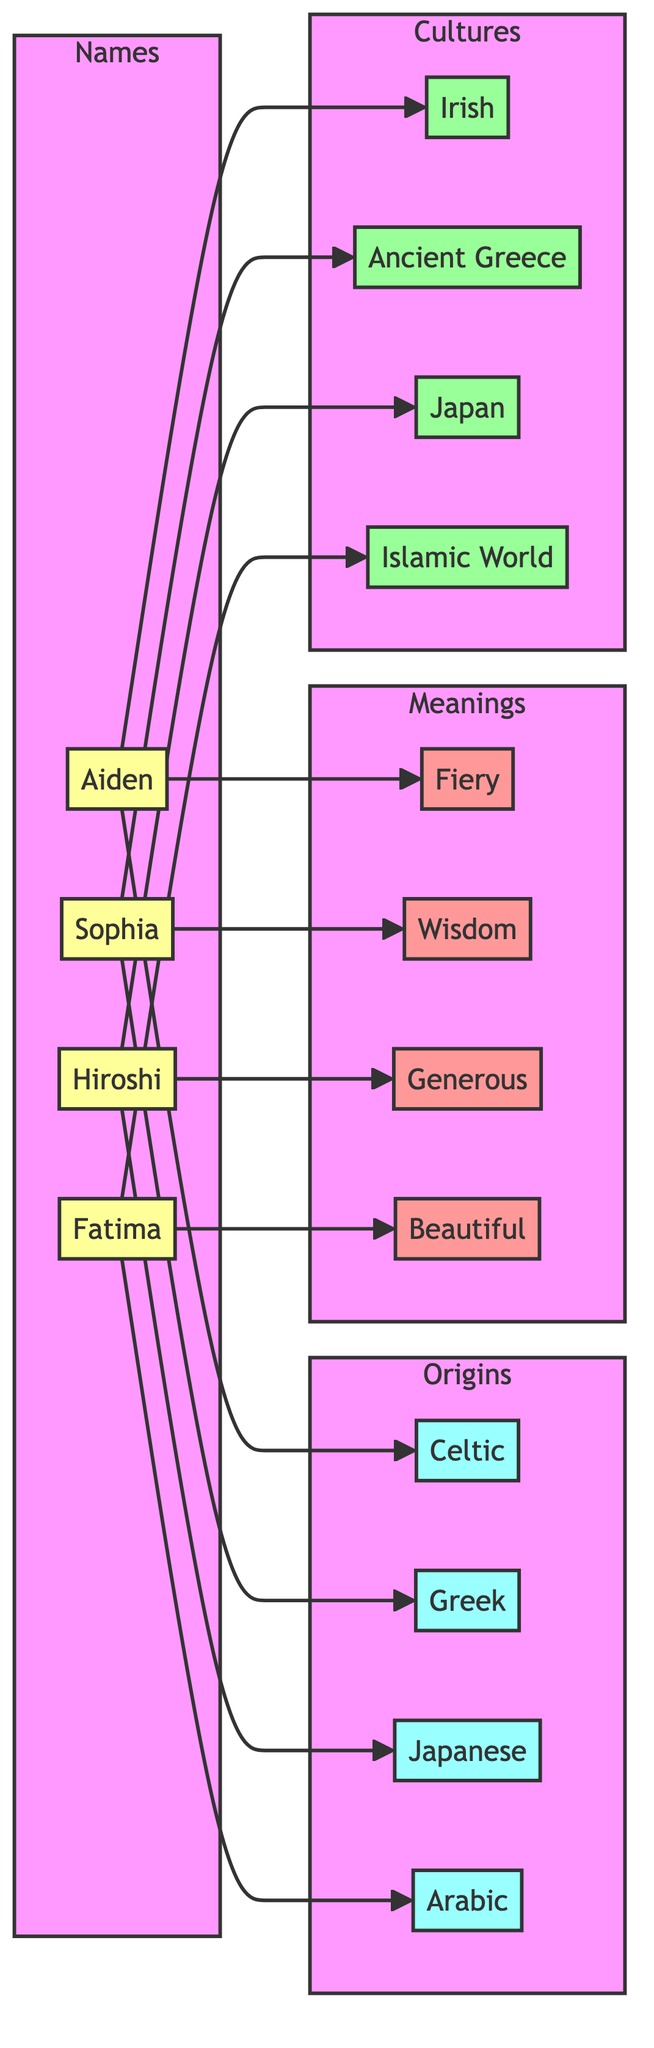What is the origin of the name "Aiden"? The diagram shows that "Aiden" is connected to "Celtic" with an edge labeled "has_origin." Thus, the origin for "Aiden" is "Celtic."
Answer: Celtic How many names are represented in the diagram? The diagram has four nodes in the "Names" subgraph: Aiden, Sophia, Hiroshi, and Fatima. Counting these nodes gives us a total of four names.
Answer: 4 Which name is associated with the culture of "Japan"? The diagram indicates that "Hiroshi" is connected to "Japan" in the "associated_with" relationship. Hence, "Hiroshi" is the name associated with the culture of Japan.
Answer: Hiroshi What does the name "Fatima" mean? The edge from "Fatima" to "Beautiful" indicates a relationship labeled "means." Therefore, the meaning of the name "Fatima" is "Beautiful."
Answer: Beautiful Which name has the meaning of "Fiery"? The diagram shows that "Aiden" is connected to "Fiery" with the relationship "means." Thus, "Aiden" is the name that means "Fiery."
Answer: Aiden How many origins are represented in the diagram? There are four nodes in the "Origins" subgraph: Celtic, Greek, Japanese, and Arabic. Counting these nodes gives us a total of four origins represented in the diagram.
Answer: 4 Which names are associated with the culture of "Ancient Greece"? The diagram indicates that "Sophia" has an association with "Ancient Greece" shown by the connection under the "associated_with" label. Therefore, the name associated with the culture of Ancient Greece is "Sophia."
Answer: Sophia What is the meaning of the name "Hiroshi"? The edge connecting "Hiroshi" to "Generous" shows the meaning associated with the name. Thus, the meaning of "Hiroshi" is "Generous."
Answer: Generous How many edges are there connecting names to their meanings? The diagram indicates three edges leading from the names to their respective meanings: Aiden to Fiery, Sophia to Wisdom, Hiroshi to Generous, and Fatima to Beautiful. This results in a total of four edges connecting names to their meanings.
Answer: 4 